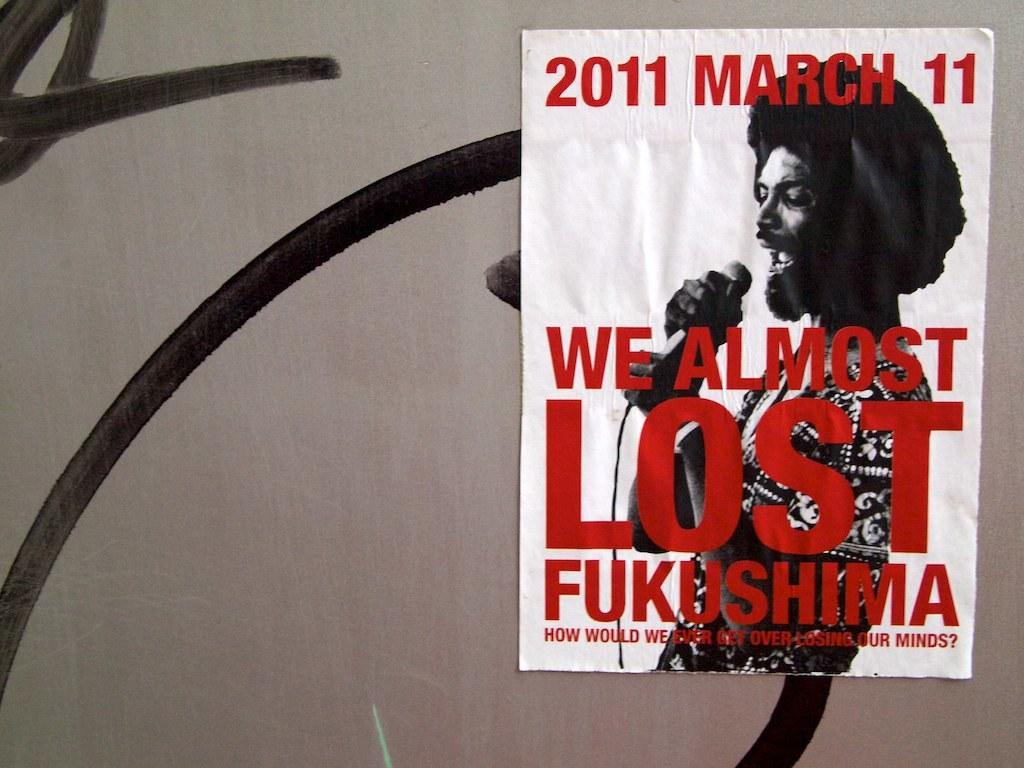<image>
Give a short and clear explanation of the subsequent image. A poster for Fukushima dated March 11 2011. 